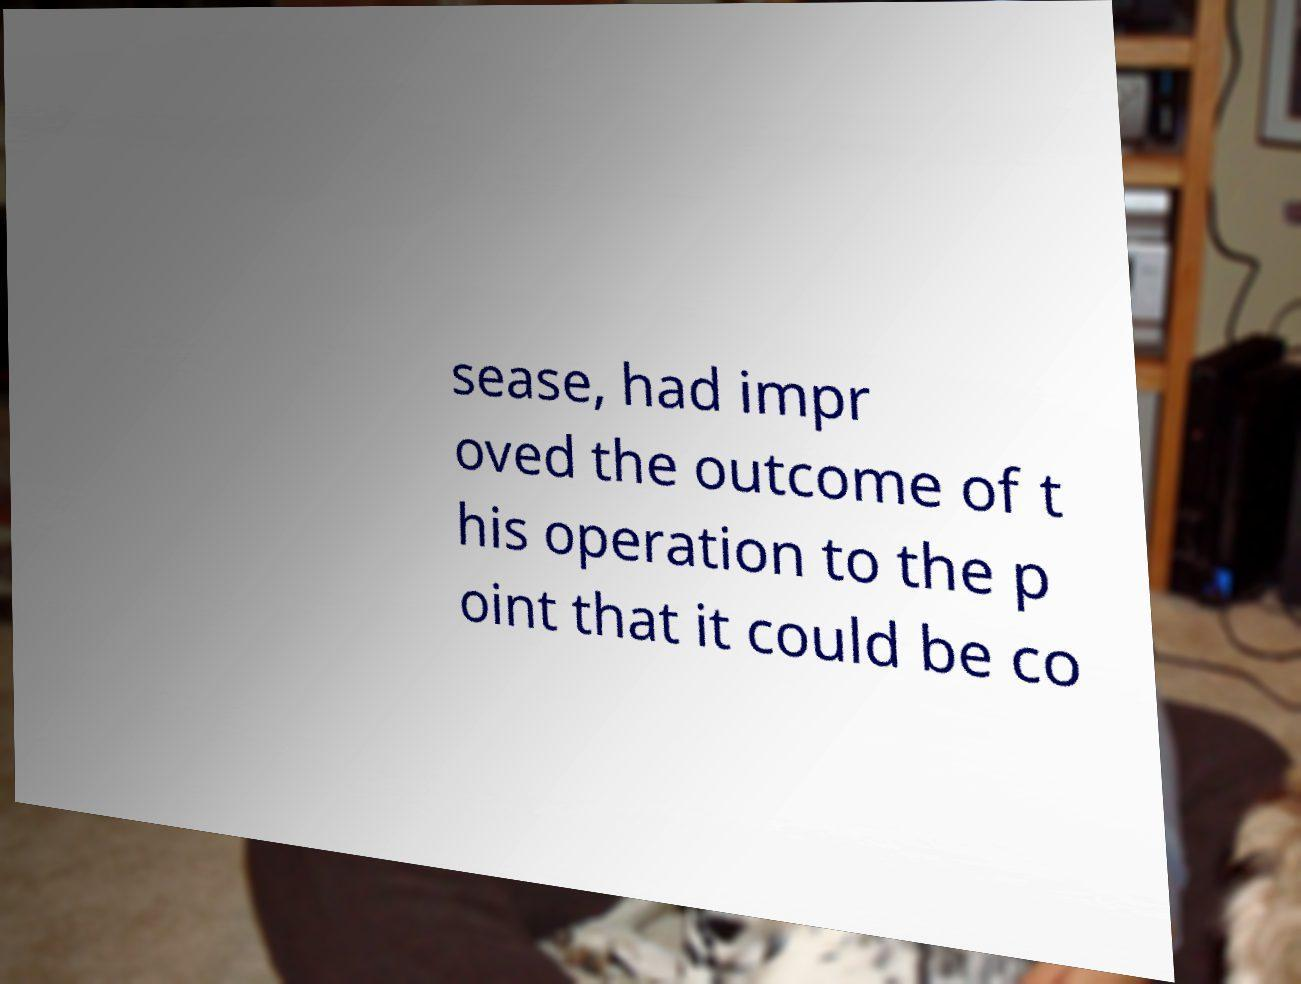Can you read and provide the text displayed in the image?This photo seems to have some interesting text. Can you extract and type it out for me? sease, had impr oved the outcome of t his operation to the p oint that it could be co 